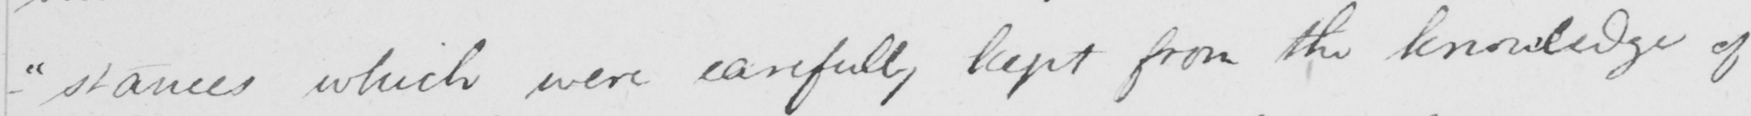Transcribe the text shown in this historical manuscript line. - " stances which were carefully kept from the knowledge of 